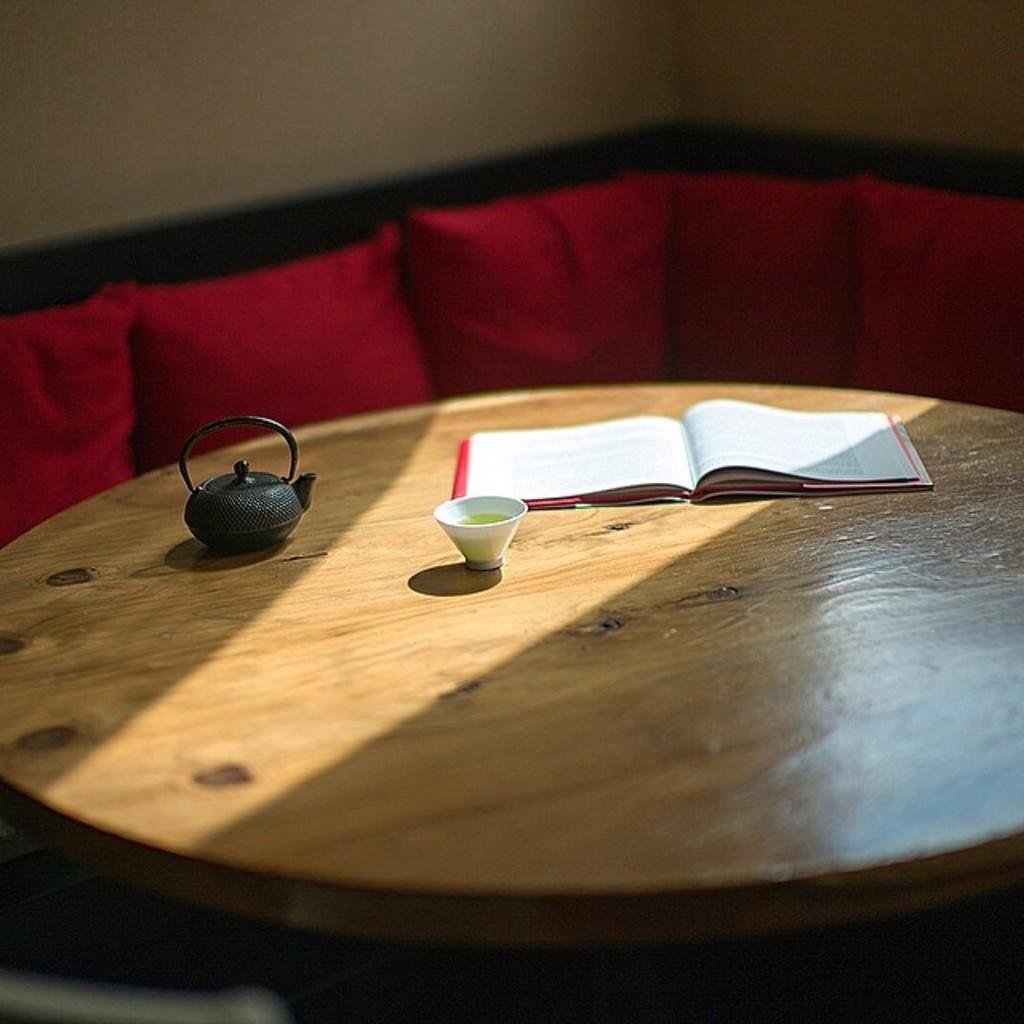Describe this image in one or two sentences. In this picture we can see a table and on table we have a mini tea pot, glass, book opened and aside to this table we have a sofa with pillows on it and in the background we can see wall. 